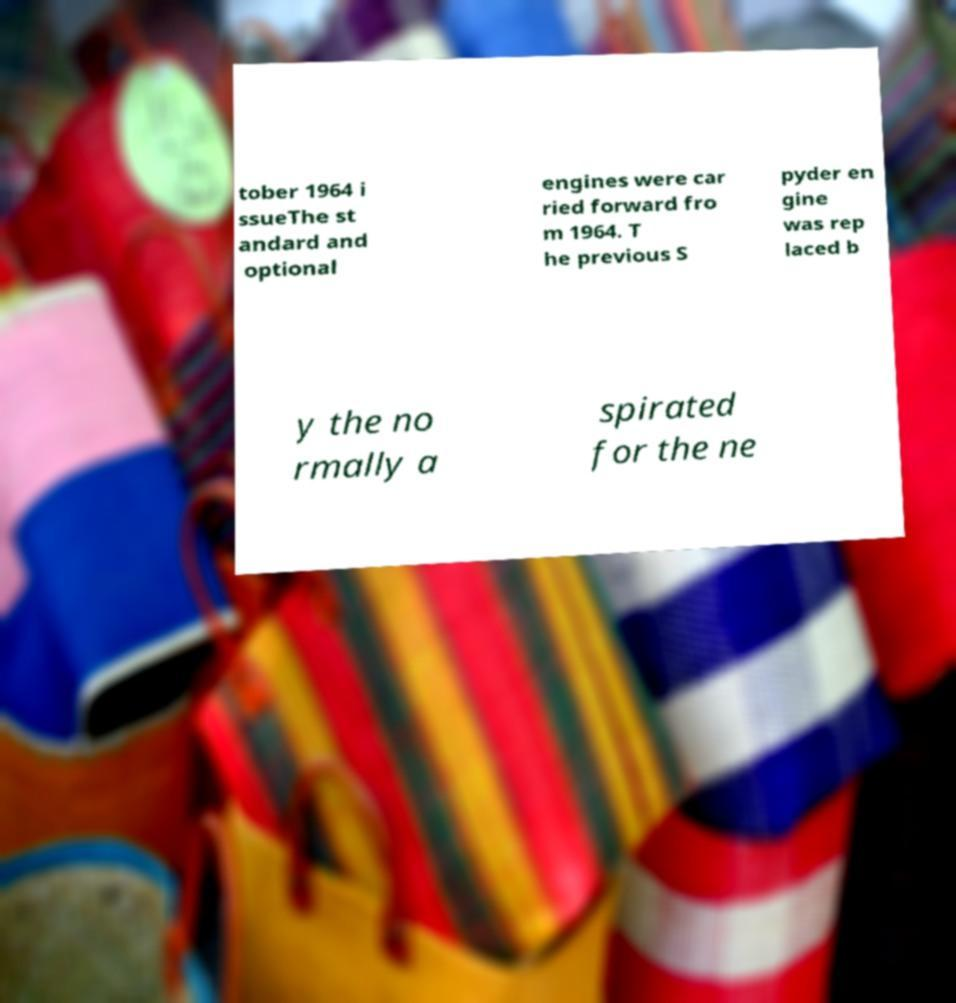There's text embedded in this image that I need extracted. Can you transcribe it verbatim? tober 1964 i ssueThe st andard and optional engines were car ried forward fro m 1964. T he previous S pyder en gine was rep laced b y the no rmally a spirated for the ne 